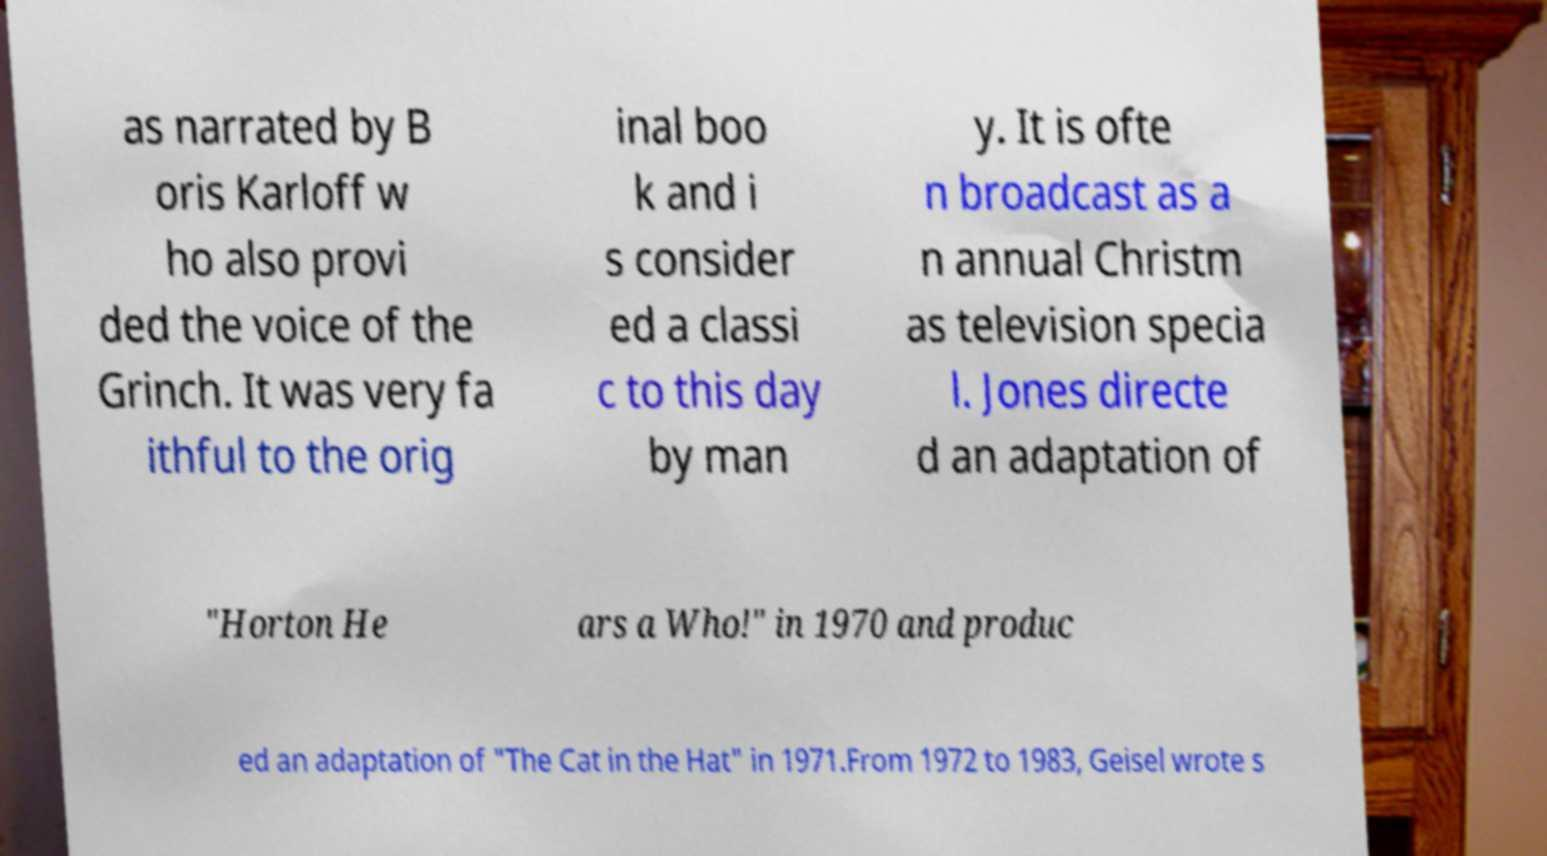Can you read and provide the text displayed in the image?This photo seems to have some interesting text. Can you extract and type it out for me? as narrated by B oris Karloff w ho also provi ded the voice of the Grinch. It was very fa ithful to the orig inal boo k and i s consider ed a classi c to this day by man y. It is ofte n broadcast as a n annual Christm as television specia l. Jones directe d an adaptation of "Horton He ars a Who!" in 1970 and produc ed an adaptation of "The Cat in the Hat" in 1971.From 1972 to 1983, Geisel wrote s 